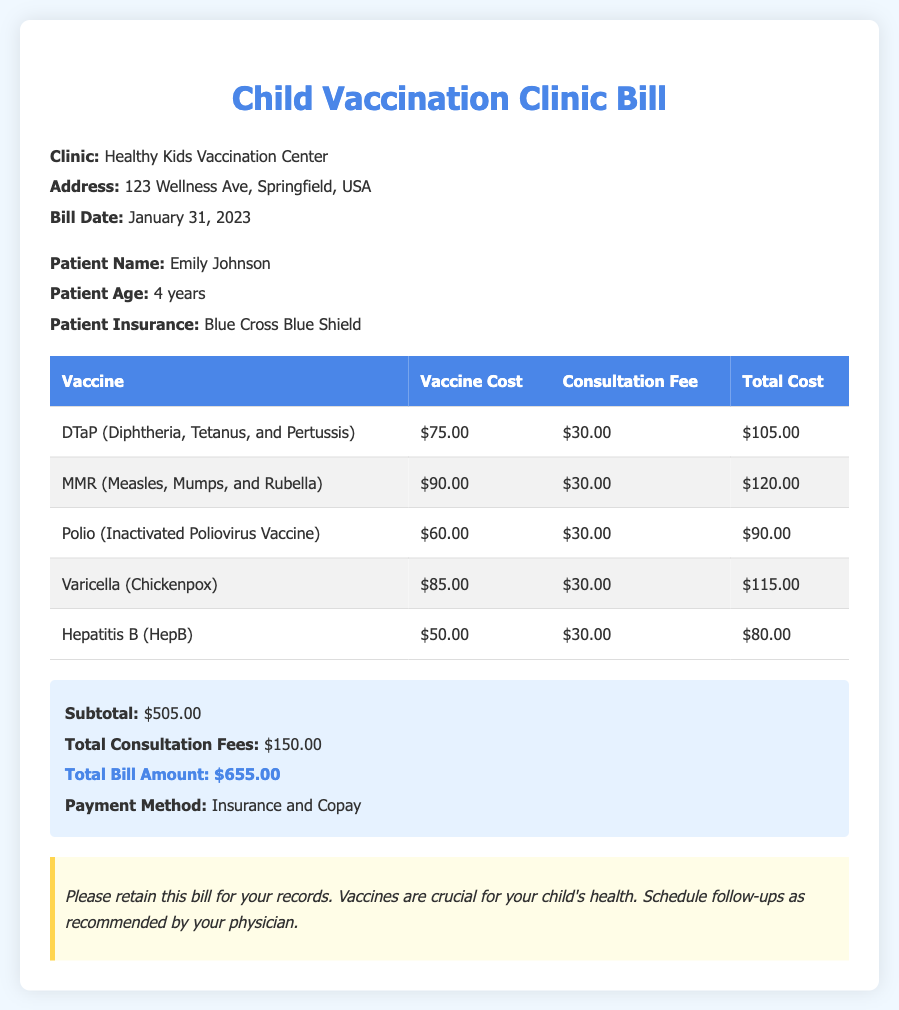What is the name of the clinic? The document states the name of the clinic as "Healthy Kids Vaccination Center."
Answer: Healthy Kids Vaccination Center What is the total bill amount? The total bill amount is clearly mentioned in the summary section of the document.
Answer: $655.00 How much does the DTaP vaccine cost? The cost of the DTaP vaccine is specified in the table under the "Vaccine Cost" column.
Answer: $75.00 What is the consultation fee for each vaccine? The consultation fee for each vaccine is consistently listed as $30.00 in the table.
Answer: $30.00 How many vaccines were administered? By counting the number of rows in the vaccine table, we can determine the number of vaccines given.
Answer: 5 What is the patient’s age? The patient’s age is provided in the patient information section of the document.
Answer: 4 years What payment method was used? The payment method is outlined in the summary section of the document.
Answer: Insurance and Copay What is the total consultation fees amount? The total consultation fees is calculated and stated in the summary section of the document.
Answer: $150.00 What is the address of the clinic? The address of the clinic is provided in the clinic information section of the document.
Answer: 123 Wellness Ave, Springfield, USA 